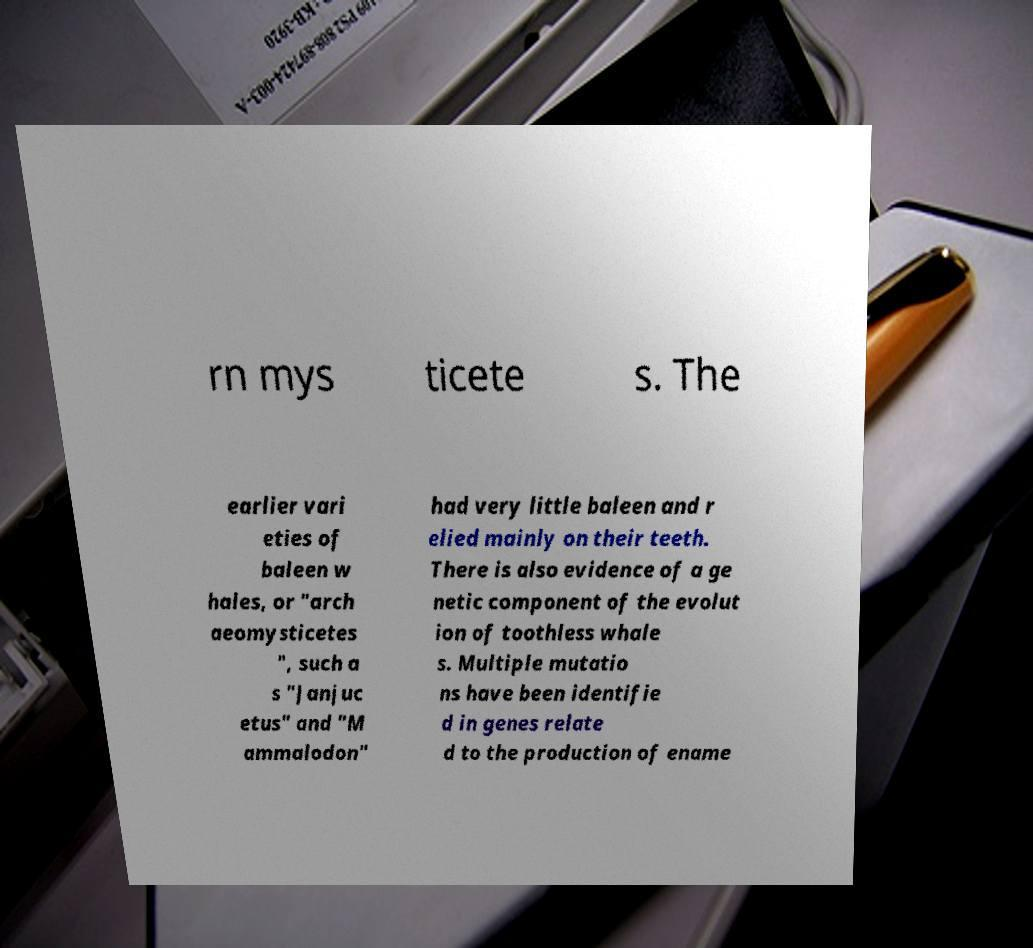Could you extract and type out the text from this image? rn mys ticete s. The earlier vari eties of baleen w hales, or "arch aeomysticetes ", such a s "Janjuc etus" and "M ammalodon" had very little baleen and r elied mainly on their teeth. There is also evidence of a ge netic component of the evolut ion of toothless whale s. Multiple mutatio ns have been identifie d in genes relate d to the production of ename 